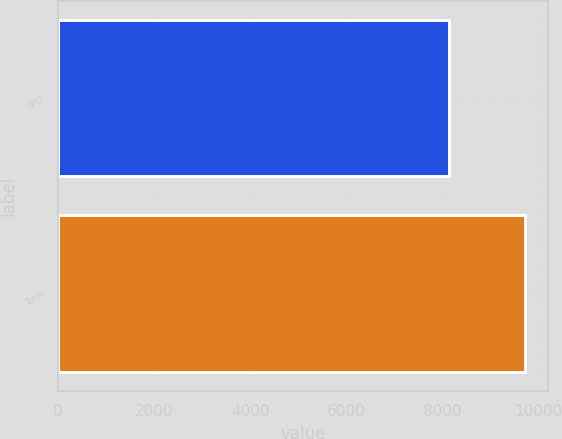<chart> <loc_0><loc_0><loc_500><loc_500><bar_chart><fcel>GPU<fcel>Total<nl><fcel>8137<fcel>9714<nl></chart> 